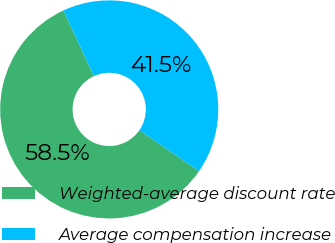<chart> <loc_0><loc_0><loc_500><loc_500><pie_chart><fcel>Weighted-average discount rate<fcel>Average compensation increase<nl><fcel>58.52%<fcel>41.48%<nl></chart> 